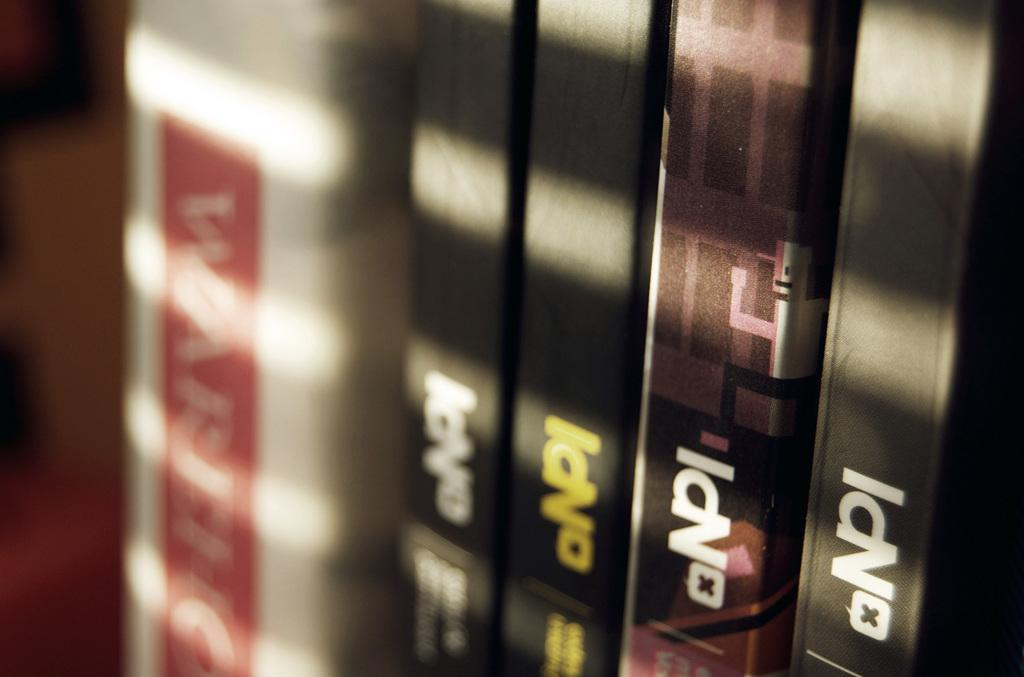<image>
Offer a succinct explanation of the picture presented. Several books by NPI sit on a shelf with sunbeams flowing across 